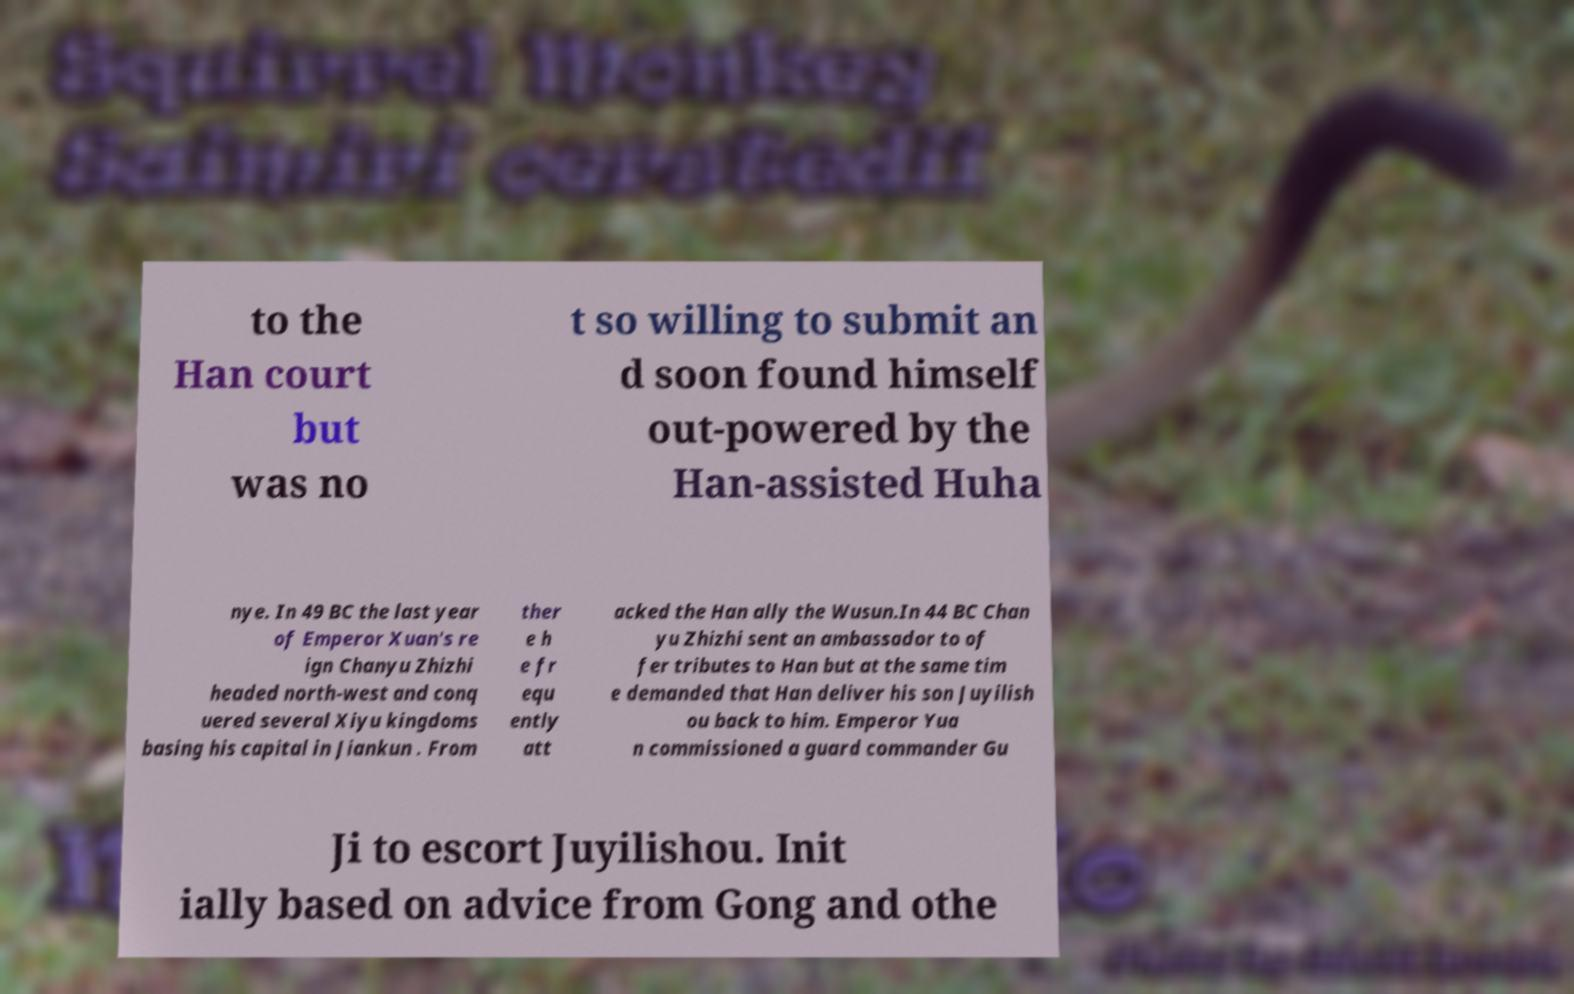Can you accurately transcribe the text from the provided image for me? to the Han court but was no t so willing to submit an d soon found himself out-powered by the Han-assisted Huha nye. In 49 BC the last year of Emperor Xuan's re ign Chanyu Zhizhi headed north-west and conq uered several Xiyu kingdoms basing his capital in Jiankun . From ther e h e fr equ ently att acked the Han ally the Wusun.In 44 BC Chan yu Zhizhi sent an ambassador to of fer tributes to Han but at the same tim e demanded that Han deliver his son Juyilish ou back to him. Emperor Yua n commissioned a guard commander Gu Ji to escort Juyilishou. Init ially based on advice from Gong and othe 